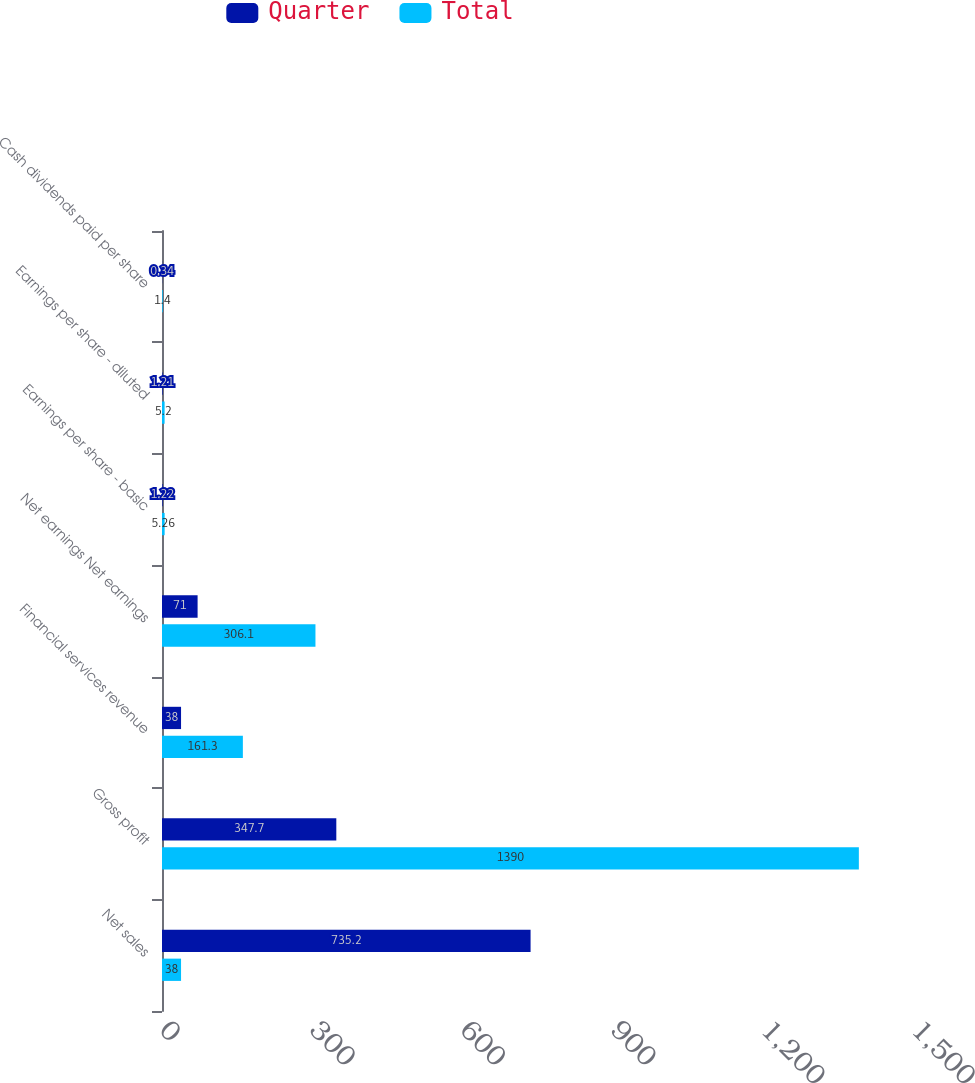Convert chart to OTSL. <chart><loc_0><loc_0><loc_500><loc_500><stacked_bar_chart><ecel><fcel>Net sales<fcel>Gross profit<fcel>Financial services revenue<fcel>Net earnings Net earnings<fcel>Earnings per share - basic<fcel>Earnings per share - diluted<fcel>Cash dividends paid per share<nl><fcel>Quarter<fcel>735.2<fcel>347.7<fcel>38<fcel>71<fcel>1.22<fcel>1.21<fcel>0.34<nl><fcel>Total<fcel>38<fcel>1390<fcel>161.3<fcel>306.1<fcel>5.26<fcel>5.2<fcel>1.4<nl></chart> 